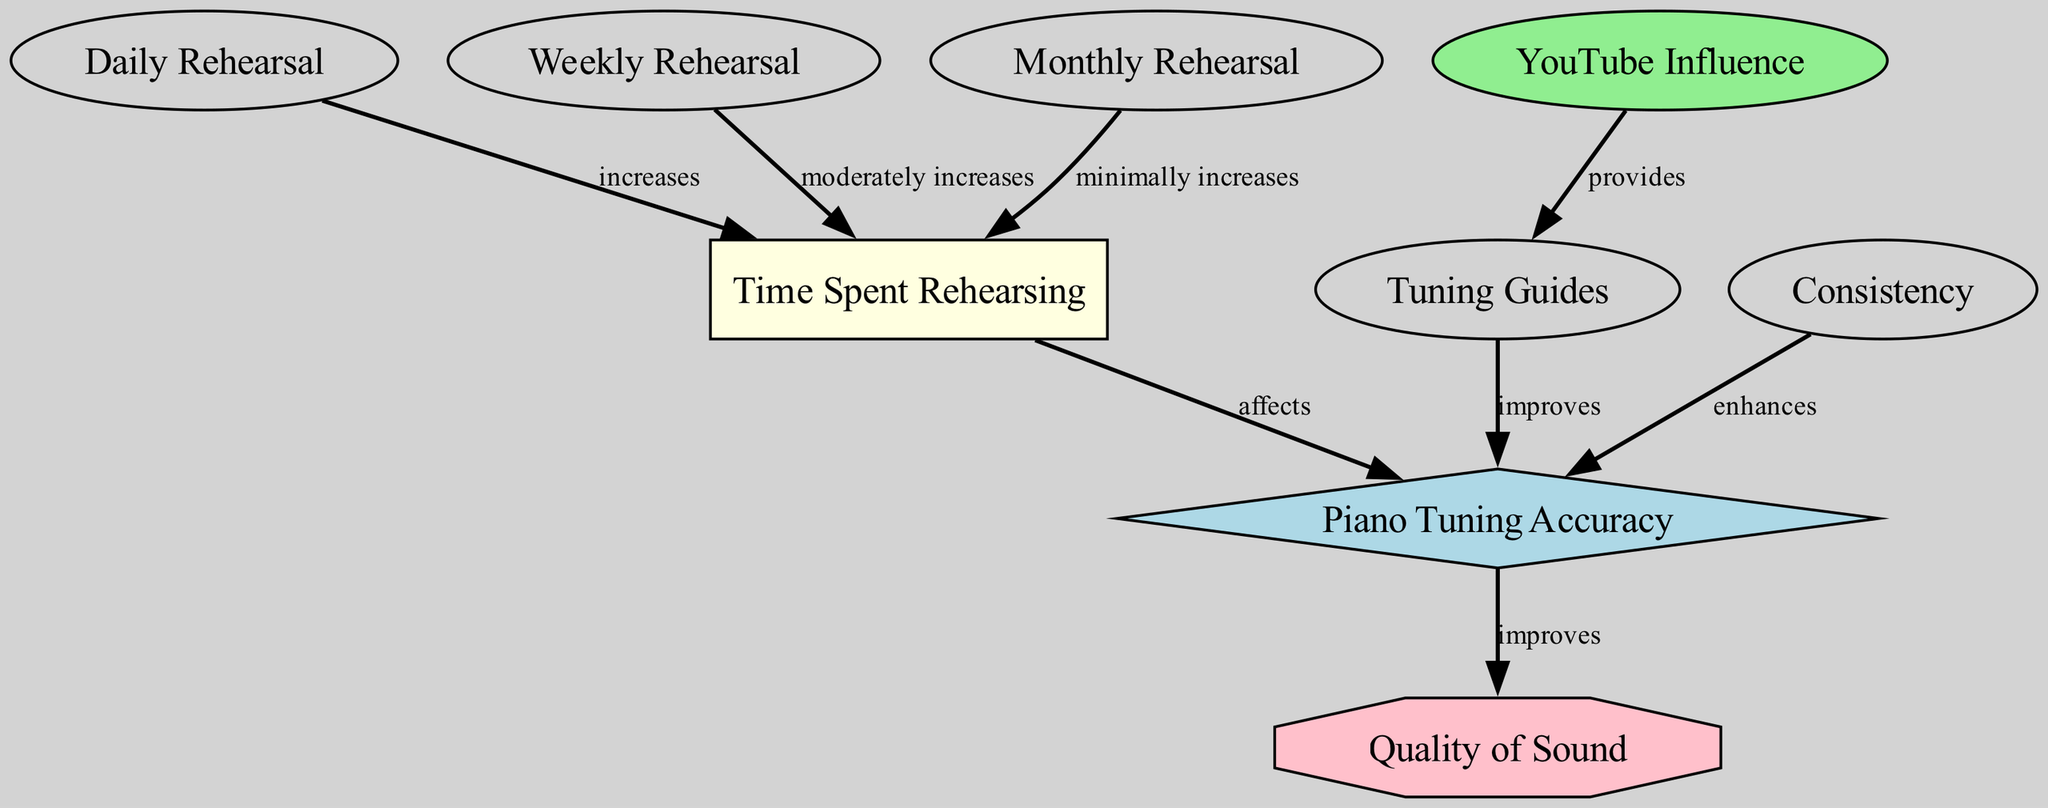What is the primary relationship depicted between time spent rehearsing and piano tuning accuracy? The diagram shows a direct relationship labeled "affects," indicating that the amount of time spent rehearsing has an influence on piano tuning accuracy.
Answer: affects How many nodes are present in this diagram? The data indicates there are nine nodes related to piano tuning accuracy and time spent rehearsing, including various rehearsal categories and influences.
Answer: nine Which node provides tuning guides? The diagram specifies that the "YouTube Influence" node provides the "Tuning Guides" node, indicating that YouTube musicians play a role in disseminating these guides.
Answer: YouTube Influence What effect do tuning guides have on piano tuning accuracy? According to the diagram, the tuning guides "improve" piano tuning accuracy, signifying a positive effect on the precision with which a piano is tuned.
Answer: improves How does daily rehearsal affect time spent rehearsing? The diagram indicates that daily rehearsal "increases" the time spent rehearsing, suggesting that more frequent practice leads to longer overall rehearsal periods.
Answer: increases What is the overall impact of piano tuning accuracy on the quality of sound? The diagram shows a direct connection labeled "improves," indicating that as piano tuning accuracy increases, the quality of sound produced also improves.
Answer: improves Which rehearsal type has a minimal effect on time spent rehearsing? The diagram indicates that monthly rehearsal has a "minimally increases" effect on time spent rehearsing, meaning it contributes the least to overall rehearsal time compared to other types.
Answer: monthlyRehearsal What factors collectively enhance piano tuning accuracy? The diagram illustrates several factors, including musician consistency and tuning guides, that collectively enhance piano tuning accuracy by showing direct relationships to it.
Answer: musicianConsistency, tuningGuides What kind of shape represents piano tuning accuracy in the diagram? The diagram specifies that piano tuning accuracy is represented by a diamond shape, highlighting its significance as a central concept in the relationships depicted.
Answer: diamond 